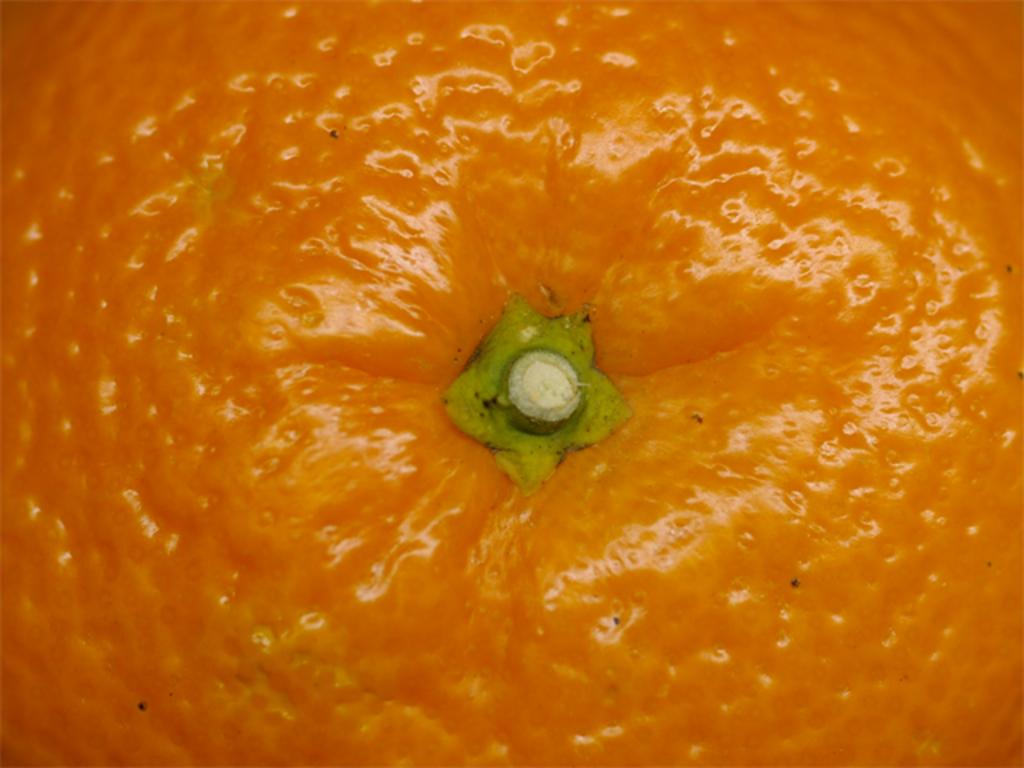What type of fruit is present in the image? There is an orange fruit in the image. Can you tell me how many times the fruit cries in the image? Fruits do not have the ability to cry, so this question cannot be answered. 